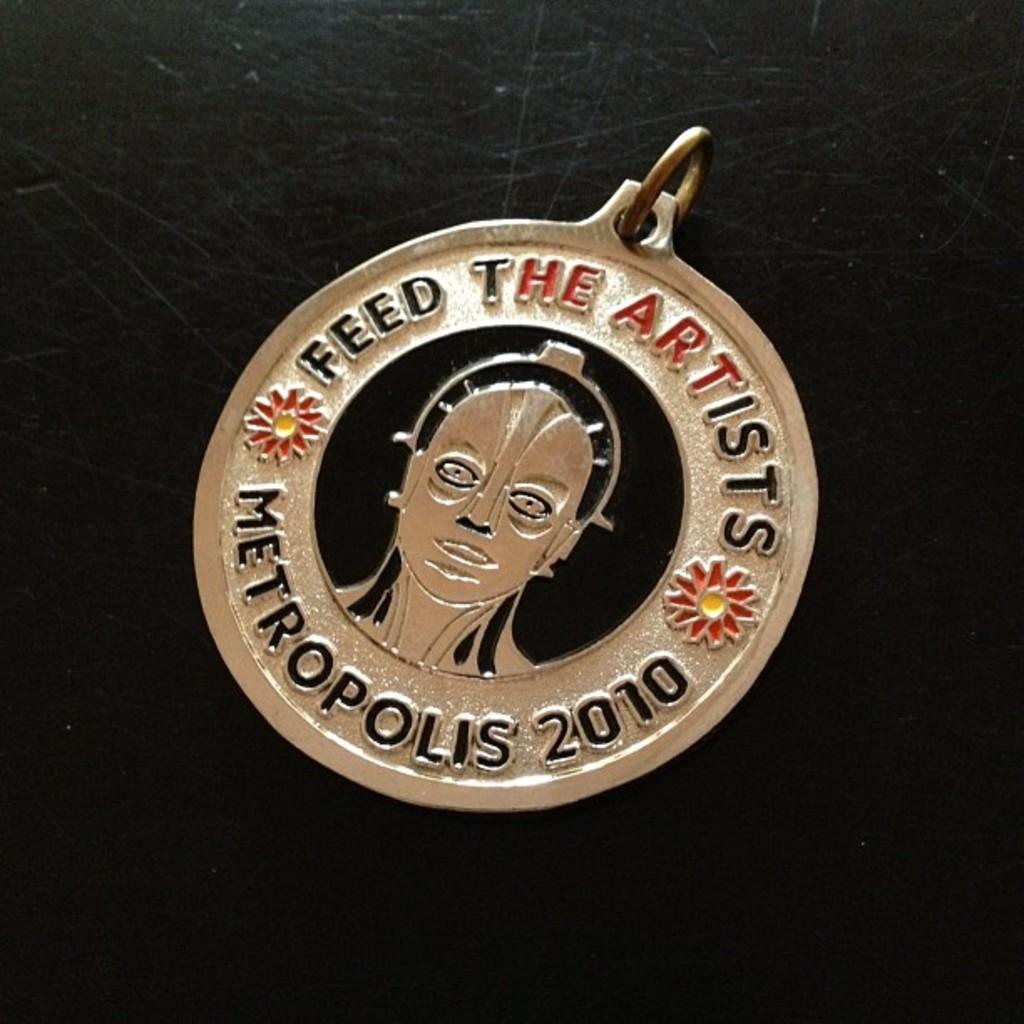What type of object is in the image? There is a locket made of metal in the image. Where is the locket located? The locket is on a table. What is the color of the table? The table is black in color. What type of dirt can be seen on the brain in the image? There is no dirt or brain present in the image; it features a metal locket on a black table. 